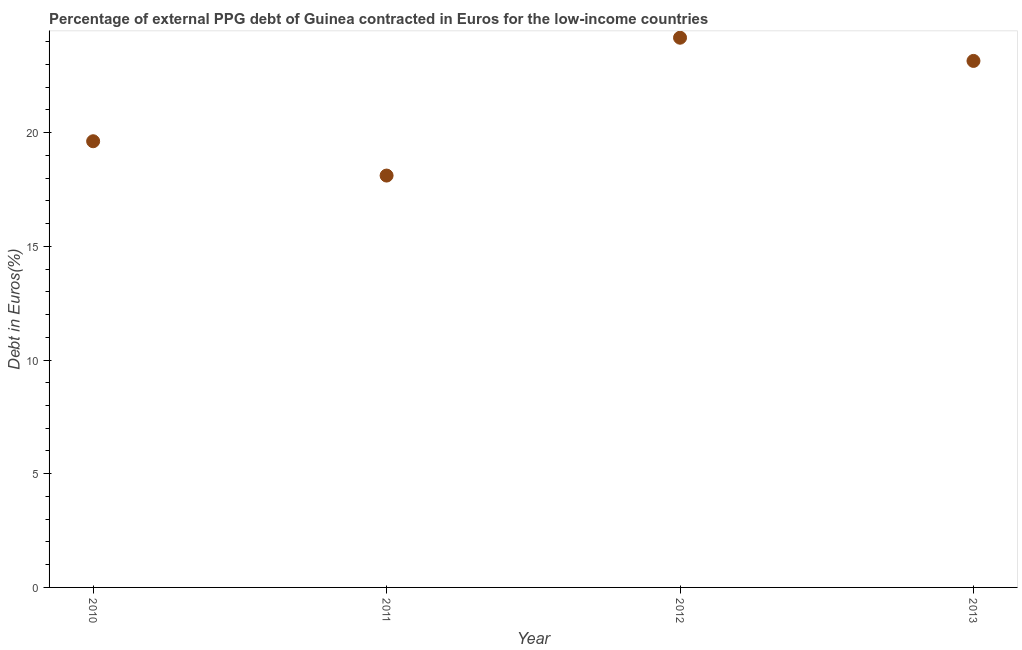What is the currency composition of ppg debt in 2013?
Your answer should be very brief. 23.15. Across all years, what is the maximum currency composition of ppg debt?
Offer a very short reply. 24.17. Across all years, what is the minimum currency composition of ppg debt?
Provide a short and direct response. 18.11. What is the sum of the currency composition of ppg debt?
Give a very brief answer. 85.05. What is the difference between the currency composition of ppg debt in 2012 and 2013?
Your response must be concise. 1.02. What is the average currency composition of ppg debt per year?
Give a very brief answer. 21.26. What is the median currency composition of ppg debt?
Give a very brief answer. 21.38. Do a majority of the years between 2013 and 2011 (inclusive) have currency composition of ppg debt greater than 5 %?
Your response must be concise. No. What is the ratio of the currency composition of ppg debt in 2012 to that in 2013?
Keep it short and to the point. 1.04. Is the currency composition of ppg debt in 2011 less than that in 2013?
Your answer should be compact. Yes. Is the difference between the currency composition of ppg debt in 2012 and 2013 greater than the difference between any two years?
Ensure brevity in your answer.  No. What is the difference between the highest and the second highest currency composition of ppg debt?
Offer a terse response. 1.02. Is the sum of the currency composition of ppg debt in 2011 and 2013 greater than the maximum currency composition of ppg debt across all years?
Give a very brief answer. Yes. What is the difference between the highest and the lowest currency composition of ppg debt?
Give a very brief answer. 6.06. In how many years, is the currency composition of ppg debt greater than the average currency composition of ppg debt taken over all years?
Your answer should be compact. 2. How many years are there in the graph?
Provide a short and direct response. 4. Does the graph contain any zero values?
Your answer should be compact. No. Does the graph contain grids?
Keep it short and to the point. No. What is the title of the graph?
Your answer should be very brief. Percentage of external PPG debt of Guinea contracted in Euros for the low-income countries. What is the label or title of the X-axis?
Your answer should be compact. Year. What is the label or title of the Y-axis?
Give a very brief answer. Debt in Euros(%). What is the Debt in Euros(%) in 2010?
Your answer should be compact. 19.62. What is the Debt in Euros(%) in 2011?
Your response must be concise. 18.11. What is the Debt in Euros(%) in 2012?
Your response must be concise. 24.17. What is the Debt in Euros(%) in 2013?
Your response must be concise. 23.15. What is the difference between the Debt in Euros(%) in 2010 and 2011?
Provide a short and direct response. 1.51. What is the difference between the Debt in Euros(%) in 2010 and 2012?
Provide a short and direct response. -4.55. What is the difference between the Debt in Euros(%) in 2010 and 2013?
Your response must be concise. -3.53. What is the difference between the Debt in Euros(%) in 2011 and 2012?
Your answer should be very brief. -6.06. What is the difference between the Debt in Euros(%) in 2011 and 2013?
Make the answer very short. -5.04. What is the difference between the Debt in Euros(%) in 2012 and 2013?
Provide a succinct answer. 1.02. What is the ratio of the Debt in Euros(%) in 2010 to that in 2011?
Offer a very short reply. 1.08. What is the ratio of the Debt in Euros(%) in 2010 to that in 2012?
Make the answer very short. 0.81. What is the ratio of the Debt in Euros(%) in 2010 to that in 2013?
Keep it short and to the point. 0.85. What is the ratio of the Debt in Euros(%) in 2011 to that in 2012?
Make the answer very short. 0.75. What is the ratio of the Debt in Euros(%) in 2011 to that in 2013?
Offer a terse response. 0.78. What is the ratio of the Debt in Euros(%) in 2012 to that in 2013?
Your answer should be compact. 1.04. 